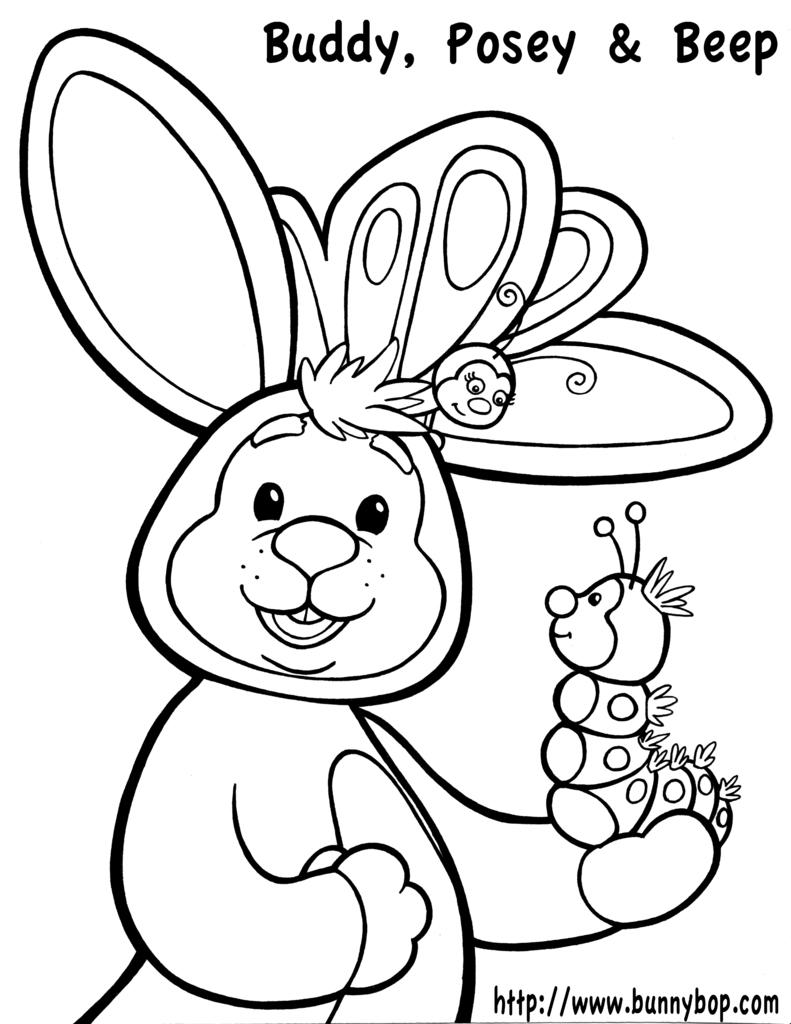What type of drawing is depicted in the image? The image is a sketch. What kind of images can be seen in the sketch? There are cartoon pictures in the sketch. Is there any written content in the sketch? Yes, there is text in the sketch. What type of silk is used to create the cartoon pictures in the sketch? There is no mention of silk in the image, as it is a sketch with cartoon pictures and text. 